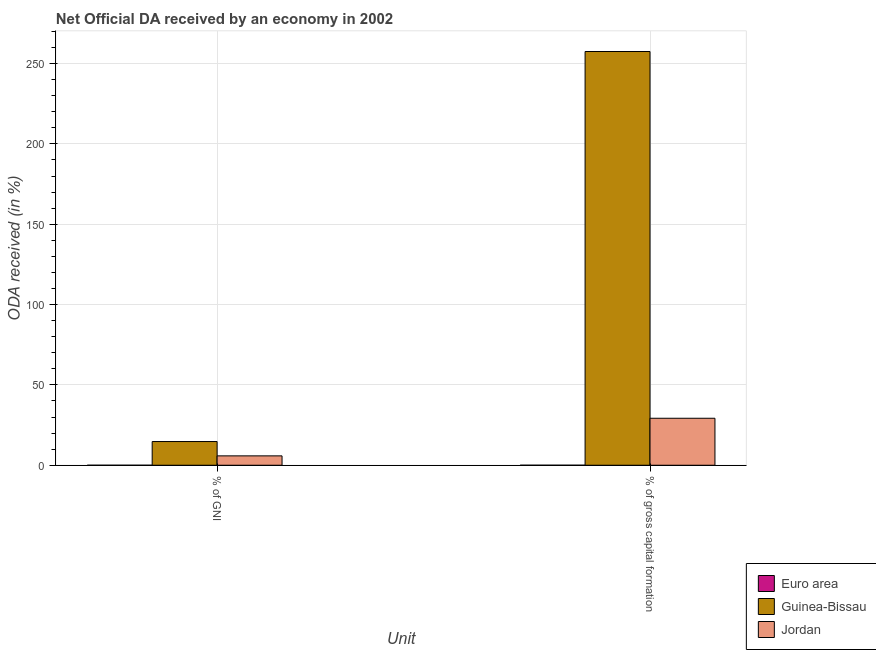How many groups of bars are there?
Provide a succinct answer. 2. Are the number of bars per tick equal to the number of legend labels?
Your answer should be very brief. Yes. How many bars are there on the 1st tick from the right?
Offer a terse response. 3. What is the label of the 2nd group of bars from the left?
Ensure brevity in your answer.  % of gross capital formation. What is the oda received as percentage of gni in Jordan?
Offer a terse response. 5.83. Across all countries, what is the maximum oda received as percentage of gross capital formation?
Make the answer very short. 257.5. Across all countries, what is the minimum oda received as percentage of gni?
Keep it short and to the point. 0. In which country was the oda received as percentage of gross capital formation maximum?
Provide a short and direct response. Guinea-Bissau. In which country was the oda received as percentage of gross capital formation minimum?
Your response must be concise. Euro area. What is the total oda received as percentage of gni in the graph?
Your response must be concise. 20.58. What is the difference between the oda received as percentage of gni in Euro area and that in Guinea-Bissau?
Give a very brief answer. -14.75. What is the difference between the oda received as percentage of gni in Guinea-Bissau and the oda received as percentage of gross capital formation in Jordan?
Keep it short and to the point. -14.5. What is the average oda received as percentage of gross capital formation per country?
Make the answer very short. 95.58. What is the difference between the oda received as percentage of gni and oda received as percentage of gross capital formation in Jordan?
Ensure brevity in your answer.  -23.41. In how many countries, is the oda received as percentage of gross capital formation greater than 80 %?
Provide a succinct answer. 1. What is the ratio of the oda received as percentage of gni in Jordan to that in Euro area?
Offer a terse response. 6512.31. Is the oda received as percentage of gni in Euro area less than that in Jordan?
Your answer should be compact. Yes. What does the 2nd bar from the left in % of GNI represents?
Offer a terse response. Guinea-Bissau. What does the 1st bar from the right in % of GNI represents?
Provide a succinct answer. Jordan. Are all the bars in the graph horizontal?
Keep it short and to the point. No. How many countries are there in the graph?
Your response must be concise. 3. Does the graph contain grids?
Ensure brevity in your answer.  Yes. How are the legend labels stacked?
Your answer should be compact. Vertical. What is the title of the graph?
Make the answer very short. Net Official DA received by an economy in 2002. What is the label or title of the X-axis?
Provide a short and direct response. Unit. What is the label or title of the Y-axis?
Your response must be concise. ODA received (in %). What is the ODA received (in %) of Euro area in % of GNI?
Offer a terse response. 0. What is the ODA received (in %) in Guinea-Bissau in % of GNI?
Provide a succinct answer. 14.75. What is the ODA received (in %) of Jordan in % of GNI?
Provide a short and direct response. 5.83. What is the ODA received (in %) of Euro area in % of gross capital formation?
Make the answer very short. 0. What is the ODA received (in %) in Guinea-Bissau in % of gross capital formation?
Your answer should be very brief. 257.5. What is the ODA received (in %) of Jordan in % of gross capital formation?
Ensure brevity in your answer.  29.24. Across all Unit, what is the maximum ODA received (in %) in Euro area?
Offer a terse response. 0. Across all Unit, what is the maximum ODA received (in %) in Guinea-Bissau?
Make the answer very short. 257.5. Across all Unit, what is the maximum ODA received (in %) of Jordan?
Offer a terse response. 29.24. Across all Unit, what is the minimum ODA received (in %) of Euro area?
Offer a very short reply. 0. Across all Unit, what is the minimum ODA received (in %) of Guinea-Bissau?
Offer a terse response. 14.75. Across all Unit, what is the minimum ODA received (in %) in Jordan?
Offer a terse response. 5.83. What is the total ODA received (in %) of Euro area in the graph?
Offer a terse response. 0.01. What is the total ODA received (in %) of Guinea-Bissau in the graph?
Your answer should be compact. 272.24. What is the total ODA received (in %) in Jordan in the graph?
Give a very brief answer. 35.08. What is the difference between the ODA received (in %) in Euro area in % of GNI and that in % of gross capital formation?
Offer a terse response. -0. What is the difference between the ODA received (in %) in Guinea-Bissau in % of GNI and that in % of gross capital formation?
Keep it short and to the point. -242.75. What is the difference between the ODA received (in %) of Jordan in % of GNI and that in % of gross capital formation?
Give a very brief answer. -23.41. What is the difference between the ODA received (in %) in Euro area in % of GNI and the ODA received (in %) in Guinea-Bissau in % of gross capital formation?
Offer a terse response. -257.5. What is the difference between the ODA received (in %) of Euro area in % of GNI and the ODA received (in %) of Jordan in % of gross capital formation?
Ensure brevity in your answer.  -29.24. What is the difference between the ODA received (in %) in Guinea-Bissau in % of GNI and the ODA received (in %) in Jordan in % of gross capital formation?
Ensure brevity in your answer.  -14.5. What is the average ODA received (in %) of Euro area per Unit?
Offer a very short reply. 0. What is the average ODA received (in %) of Guinea-Bissau per Unit?
Your answer should be compact. 136.12. What is the average ODA received (in %) of Jordan per Unit?
Your response must be concise. 17.54. What is the difference between the ODA received (in %) in Euro area and ODA received (in %) in Guinea-Bissau in % of GNI?
Your response must be concise. -14.75. What is the difference between the ODA received (in %) in Euro area and ODA received (in %) in Jordan in % of GNI?
Your answer should be very brief. -5.83. What is the difference between the ODA received (in %) of Guinea-Bissau and ODA received (in %) of Jordan in % of GNI?
Ensure brevity in your answer.  8.92. What is the difference between the ODA received (in %) in Euro area and ODA received (in %) in Guinea-Bissau in % of gross capital formation?
Give a very brief answer. -257.49. What is the difference between the ODA received (in %) in Euro area and ODA received (in %) in Jordan in % of gross capital formation?
Keep it short and to the point. -29.24. What is the difference between the ODA received (in %) in Guinea-Bissau and ODA received (in %) in Jordan in % of gross capital formation?
Ensure brevity in your answer.  228.25. What is the ratio of the ODA received (in %) in Euro area in % of GNI to that in % of gross capital formation?
Ensure brevity in your answer.  0.22. What is the ratio of the ODA received (in %) of Guinea-Bissau in % of GNI to that in % of gross capital formation?
Give a very brief answer. 0.06. What is the ratio of the ODA received (in %) of Jordan in % of GNI to that in % of gross capital formation?
Your response must be concise. 0.2. What is the difference between the highest and the second highest ODA received (in %) in Euro area?
Offer a terse response. 0. What is the difference between the highest and the second highest ODA received (in %) in Guinea-Bissau?
Provide a succinct answer. 242.75. What is the difference between the highest and the second highest ODA received (in %) in Jordan?
Your response must be concise. 23.41. What is the difference between the highest and the lowest ODA received (in %) of Euro area?
Ensure brevity in your answer.  0. What is the difference between the highest and the lowest ODA received (in %) of Guinea-Bissau?
Offer a terse response. 242.75. What is the difference between the highest and the lowest ODA received (in %) in Jordan?
Offer a very short reply. 23.41. 